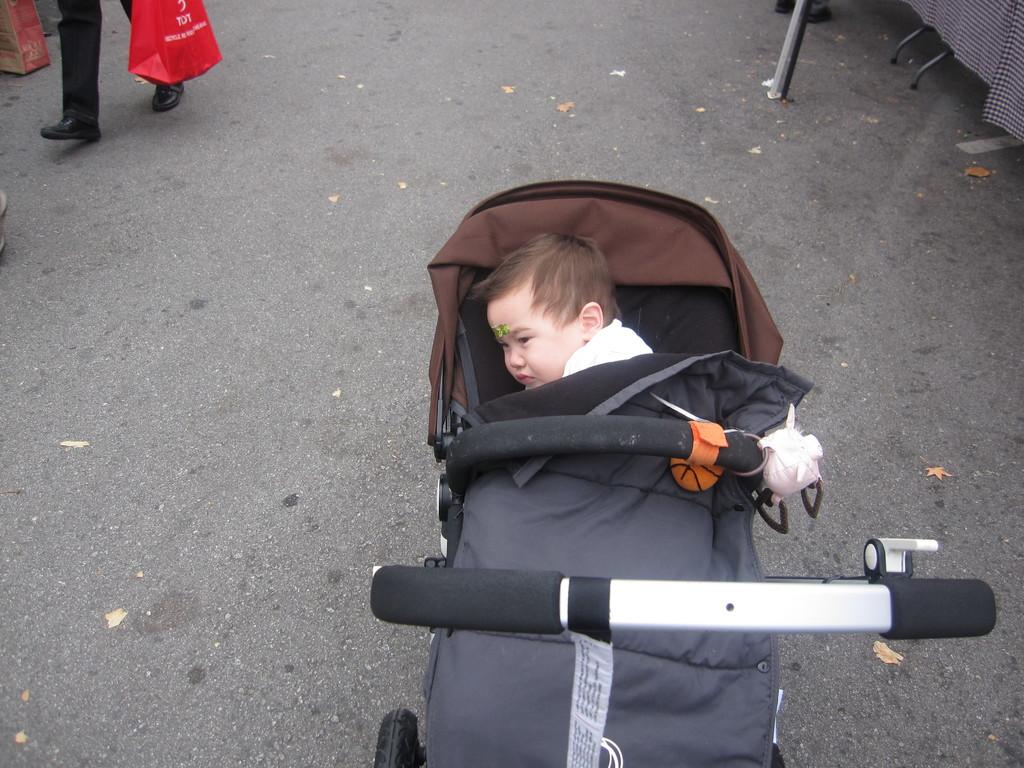What is the main subject of the image? There is a baby in a stroller in the image. How is the baby dressed? The baby is wearing a white dress. Who else is present in the image? There is a person at the left side of the image. What is the person holding? The person is holding a red bag. What type of grass is growing around the baby's stroller in the image? There is no grass visible in the image; it appears to be an urban setting. 